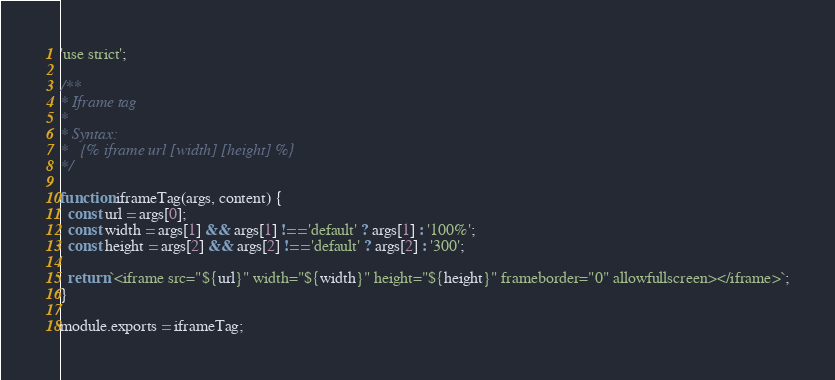<code> <loc_0><loc_0><loc_500><loc_500><_JavaScript_>'use strict';

/**
* Iframe tag
*
* Syntax:
*   {% iframe url [width] [height] %}
*/

function iframeTag(args, content) {
  const url = args[0];
  const width = args[1] && args[1] !== 'default' ? args[1] : '100%';
  const height = args[2] && args[2] !== 'default' ? args[2] : '300';

  return `<iframe src="${url}" width="${width}" height="${height}" frameborder="0" allowfullscreen></iframe>`;
}

module.exports = iframeTag;
</code> 